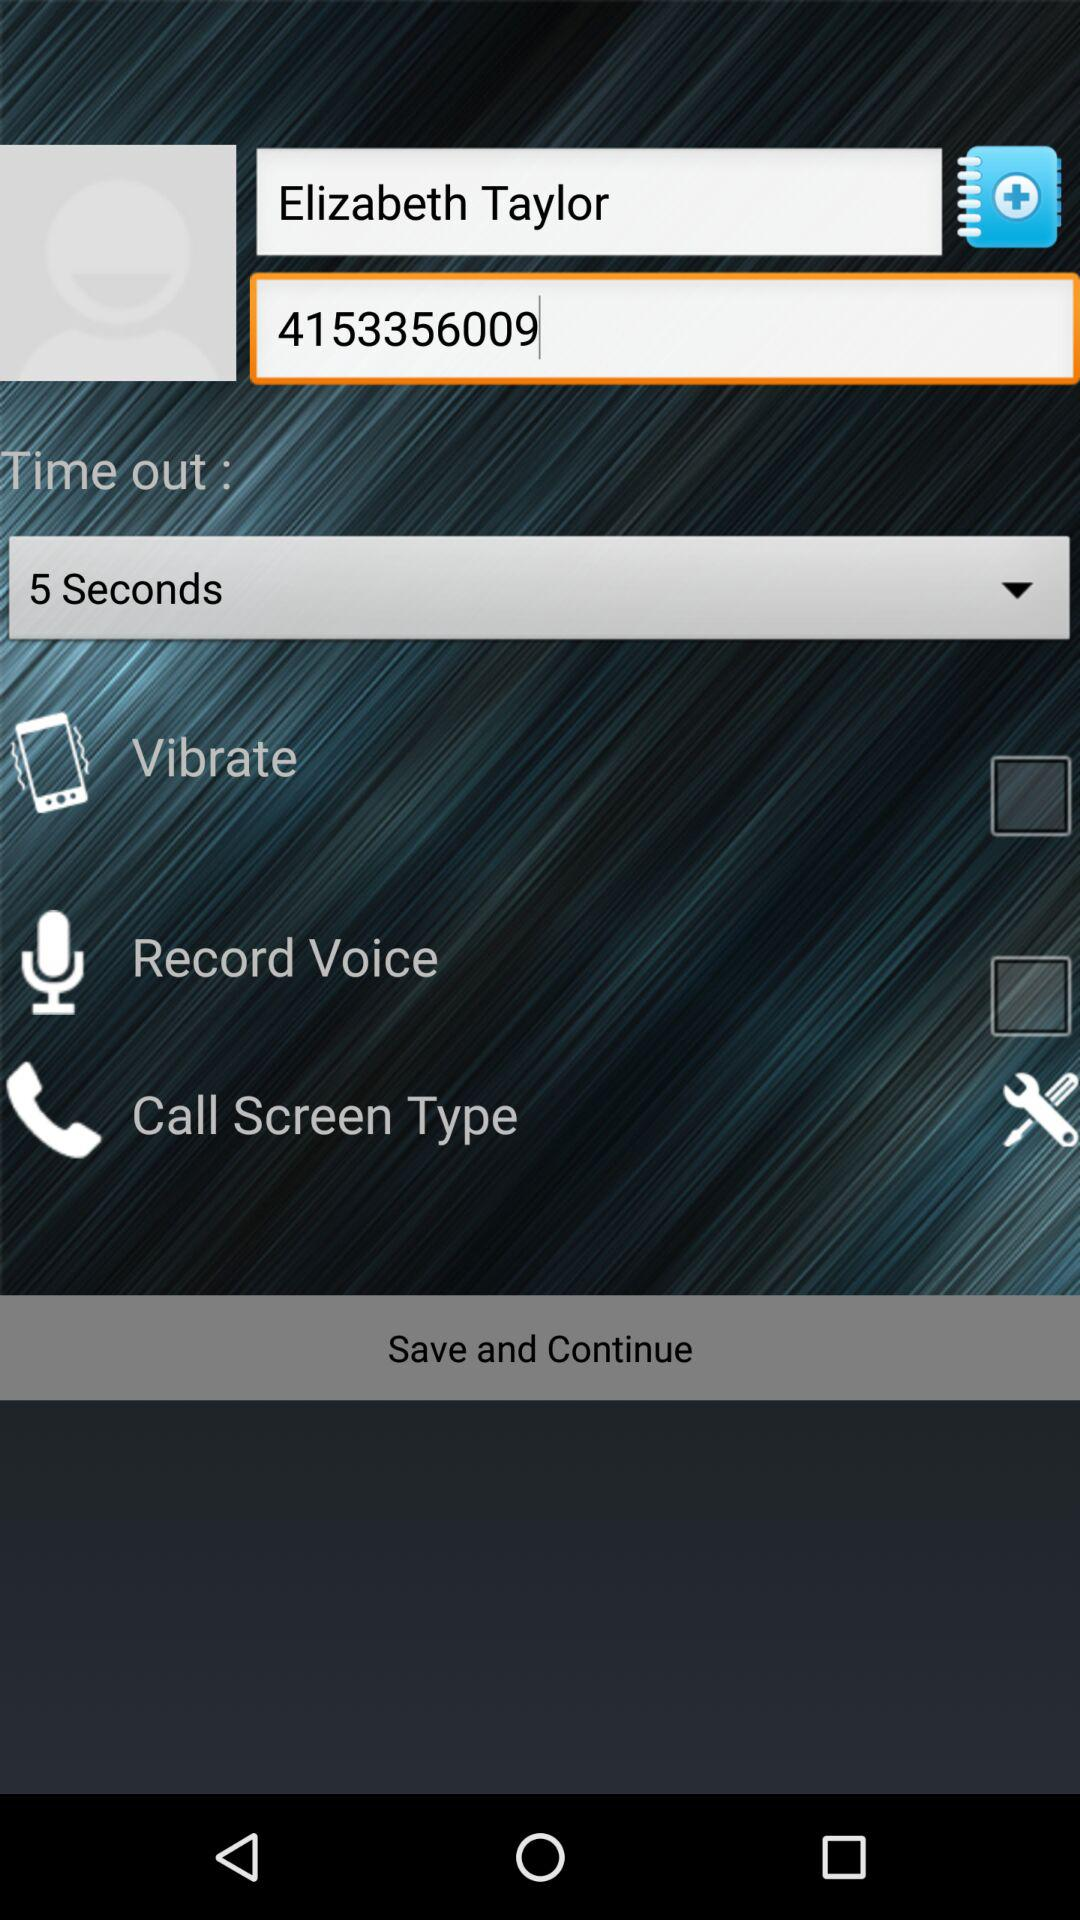What is the contact number? The contact number is 4153356009. 